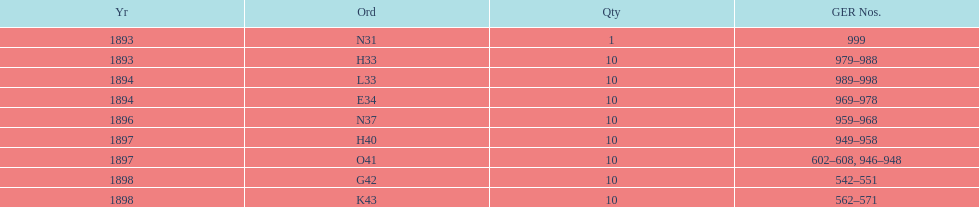How many years are listed? 5. Could you help me parse every detail presented in this table? {'header': ['Yr', 'Ord', 'Qty', 'GER Nos.'], 'rows': [['1893', 'N31', '1', '999'], ['1893', 'H33', '10', '979–988'], ['1894', 'L33', '10', '989–998'], ['1894', 'E34', '10', '969–978'], ['1896', 'N37', '10', '959–968'], ['1897', 'H40', '10', '949–958'], ['1897', 'O41', '10', '602–608, 946–948'], ['1898', 'G42', '10', '542–551'], ['1898', 'K43', '10', '562–571']]} 